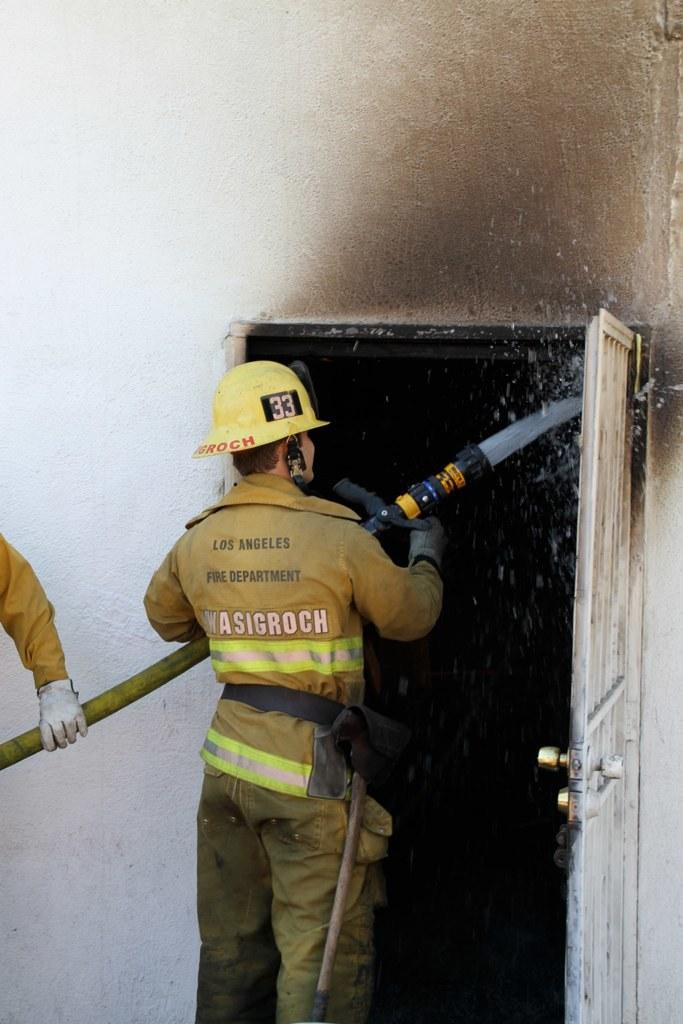What is the main subject of the image? There is a man standing in the center of the image. What is the man holding in the image? The man is holding a pipe. What type of headwear is the man wearing? The man is wearing a cap. What can be seen in the background of the image? There is a wall and a door in the background of the image. Whose hand is visible on the left side of the image? There is a person's hand on the left side of the image. What type of boat can be seen in the aftermath of the image? There is no boat present in the image, nor is there any mention of an aftermath. 